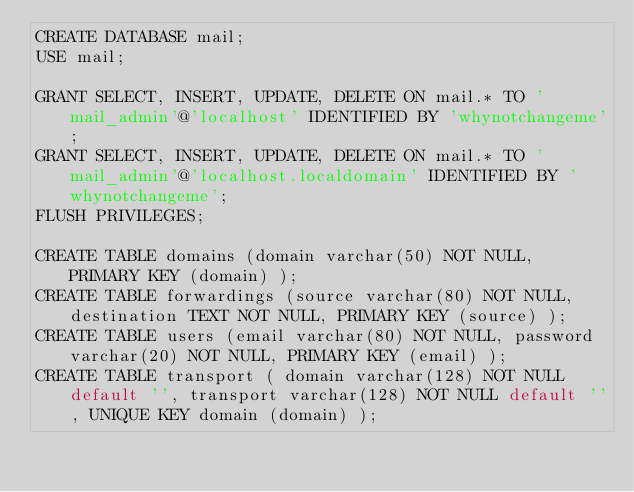Convert code to text. <code><loc_0><loc_0><loc_500><loc_500><_SQL_>CREATE DATABASE mail;
USE mail;

GRANT SELECT, INSERT, UPDATE, DELETE ON mail.* TO 'mail_admin'@'localhost' IDENTIFIED BY 'whynotchangeme';
GRANT SELECT, INSERT, UPDATE, DELETE ON mail.* TO 'mail_admin'@'localhost.localdomain' IDENTIFIED BY 'whynotchangeme';
FLUSH PRIVILEGES;

CREATE TABLE domains (domain varchar(50) NOT NULL, PRIMARY KEY (domain) );
CREATE TABLE forwardings (source varchar(80) NOT NULL, destination TEXT NOT NULL, PRIMARY KEY (source) );
CREATE TABLE users (email varchar(80) NOT NULL, password varchar(20) NOT NULL, PRIMARY KEY (email) );
CREATE TABLE transport ( domain varchar(128) NOT NULL default '', transport varchar(128) NOT NULL default '', UNIQUE KEY domain (domain) );

</code> 